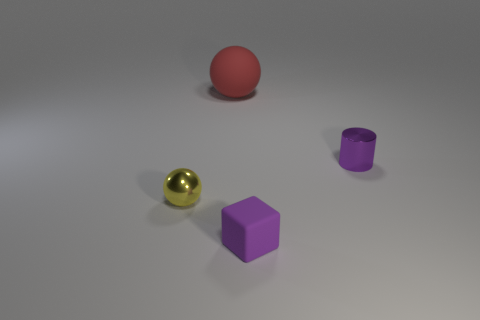Add 1 small yellow objects. How many objects exist? 5 Subtract all cylinders. How many objects are left? 3 Add 4 yellow shiny things. How many yellow shiny things exist? 5 Subtract 0 yellow cylinders. How many objects are left? 4 Subtract all big balls. Subtract all big things. How many objects are left? 2 Add 1 objects. How many objects are left? 5 